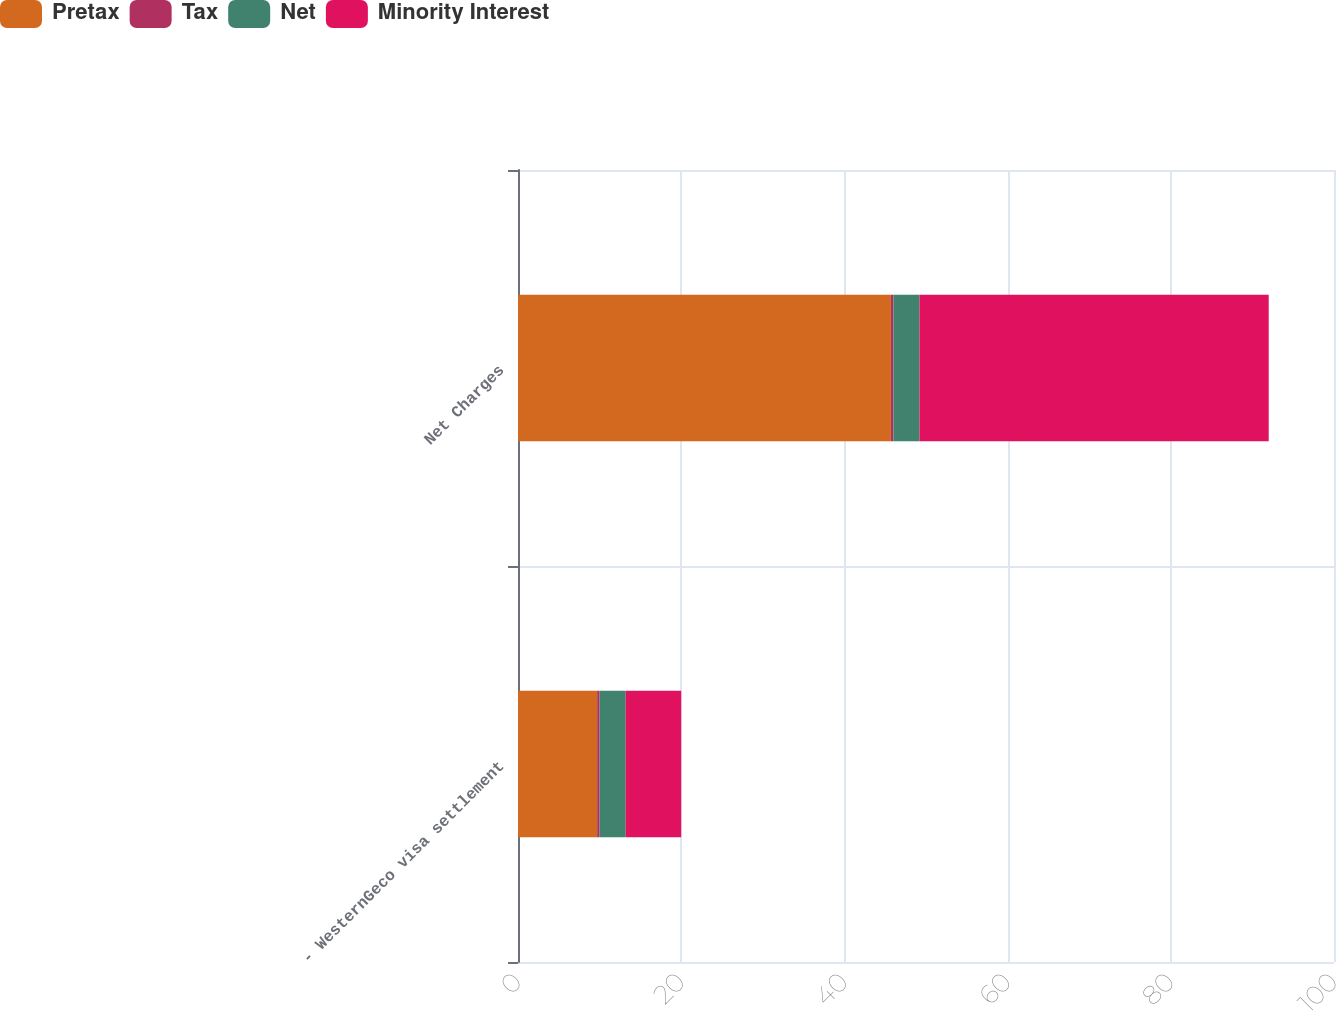Convert chart to OTSL. <chart><loc_0><loc_0><loc_500><loc_500><stacked_bar_chart><ecel><fcel>- WesternGeco visa settlement<fcel>Net Charges<nl><fcel>Pretax<fcel>9.7<fcel>45.7<nl><fcel>Tax<fcel>0.3<fcel>0.3<nl><fcel>Net<fcel>3.2<fcel>3.2<nl><fcel>Minority Interest<fcel>6.8<fcel>42.8<nl></chart> 